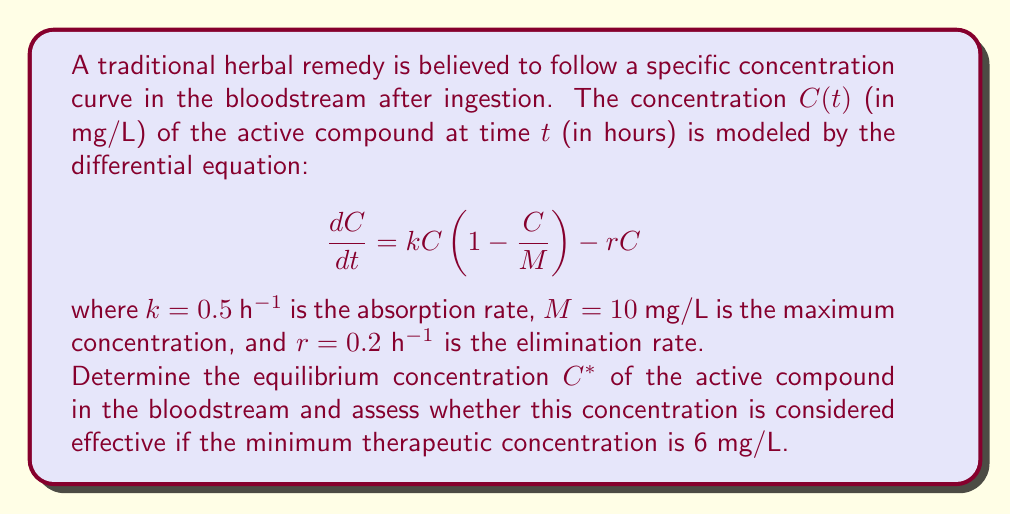Could you help me with this problem? To solve this problem, we need to follow these steps:

1) The equilibrium concentration $C^*$ occurs when $\frac{dC}{dt} = 0$. So, we set the right-hand side of the differential equation to zero:

   $$kC(1 - \frac{C}{M}) - rC = 0$$

2) Substitute the given values:

   $$0.5C(1 - \frac{C}{10}) - 0.2C = 0$$

3) Factor out $C$:

   $$C(0.5(1 - \frac{C}{10}) - 0.2) = 0$$

4) The trivial solution $C = 0$ is not of interest here. So, we solve:

   $$0.5(1 - \frac{C}{10}) - 0.2 = 0$$

5) Multiply both sides by 10:

   $$5(1 - \frac{C}{10}) - 2 = 0$$
   $$5 - \frac{C}{2} - 2 = 0$$

6) Simplify:

   $$3 - \frac{C}{2} = 0$$

7) Solve for $C$:

   $$\frac{C}{2} = 3$$
   $$C = 6$$

Thus, the equilibrium concentration $C^*$ is 6 mg/L.

To assess whether this concentration is effective, we compare it to the minimum therapeutic concentration given (6 mg/L). Since the equilibrium concentration equals the minimum therapeutic concentration, it is considered just barely effective.
Answer: The equilibrium concentration $C^*$ is 6 mg/L, which is exactly at the minimum therapeutic concentration. Therefore, the traditional remedy is considered minimally effective at equilibrium. 